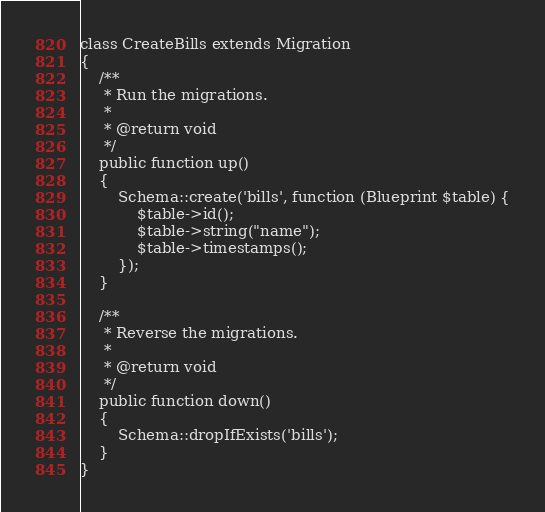Convert code to text. <code><loc_0><loc_0><loc_500><loc_500><_PHP_>class CreateBills extends Migration
{
    /**
     * Run the migrations.
     *
     * @return void
     */
    public function up()
    {
        Schema::create('bills', function (Blueprint $table) {
            $table->id();
            $table->string("name");
            $table->timestamps();
        });
    }

    /**
     * Reverse the migrations.
     *
     * @return void
     */
    public function down()
    {
        Schema::dropIfExists('bills');
    }
}
</code> 